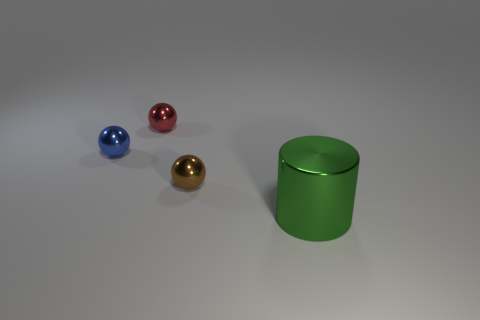Add 1 purple rubber cylinders. How many objects exist? 5 Subtract all balls. How many objects are left? 1 Add 4 small blocks. How many small blocks exist? 4 Subtract 0 green balls. How many objects are left? 4 Subtract all large red rubber blocks. Subtract all brown metallic objects. How many objects are left? 3 Add 1 big green things. How many big green things are left? 2 